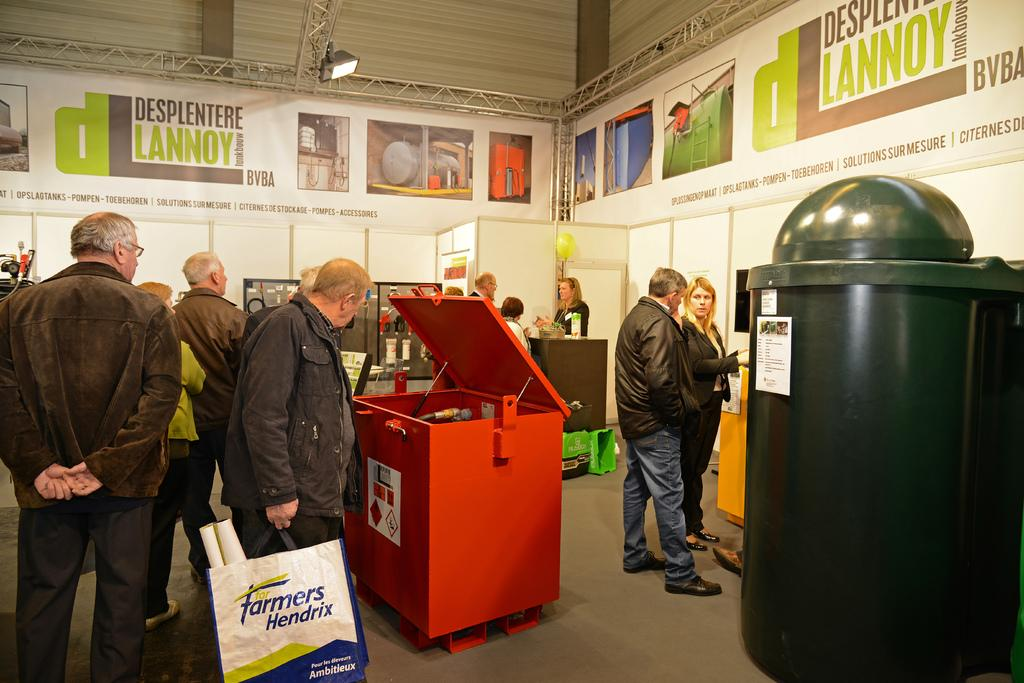<image>
Present a compact description of the photo's key features. Man looking at something while holding a bag which says "Farmers Hendrix". 